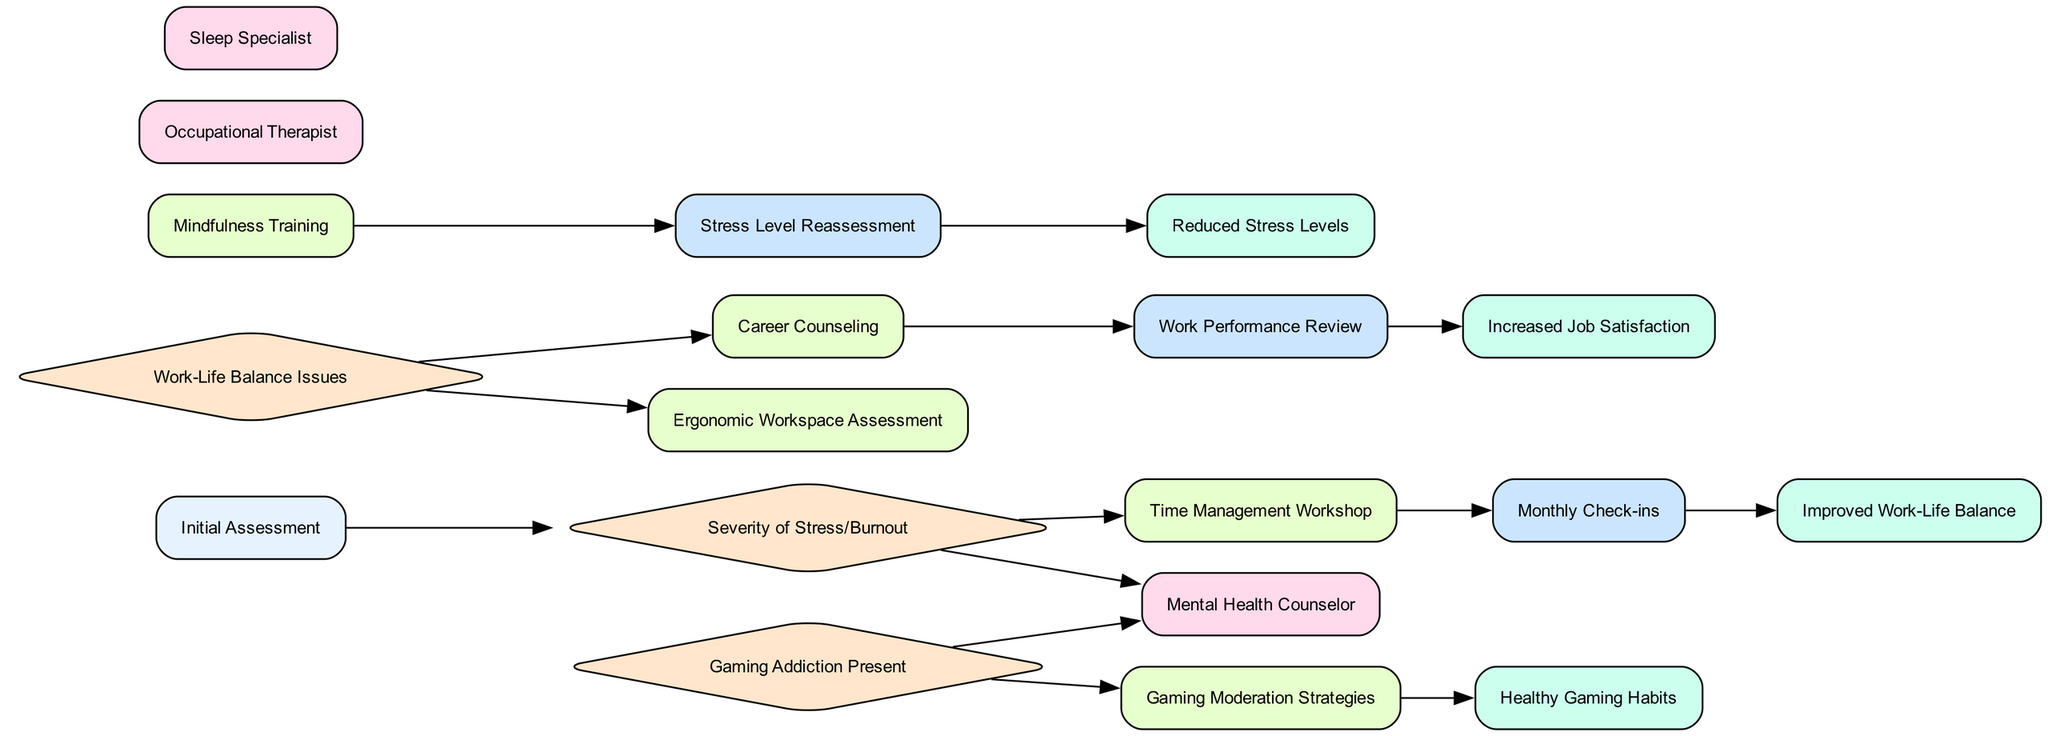What's the start point of the clinical pathway? The start point in the diagram is labeled as "Initial Assessment," which indicates the beginning of the clinical pathway and the first action taken.
Answer: Initial Assessment How many decision points are there in the diagram? By examining the diagram, we can count three clear decision points: "Severity of Stress/Burnout," "Work-Life Balance Issues," and "Gaming Addiction Present." Therefore, the total is three.
Answer: 3 What intervention is connected to 'Severity of Stress/Burnout'? The intervention directly connected to 'Severity of Stress/Burnout' is "Time Management Workshop," indicating a response based on the assessment of stress levels.
Answer: Time Management Workshop Which outcome results from 'Monthly Check-ins'? The outcome resulting from 'Monthly Check-ins' is "Improved Work-Life Balance," showing the positive effect of consistent monitoring on professionals' balance between work and personal life.
Answer: Improved Work-Life Balance What are the referrals related to the 'Gaming Addiction Present' decision point? The referrals linked to 'Gaming Addiction Present' are "Gaming Moderation Strategies" and "Mental Health Counselor." This shows the pathways that emerge when gaming addiction is identified as an issue.
Answer: Gaming Moderation Strategies, Mental Health Counselor Which intervention leads to the 'Work Performance Review'? The intervention that leads to 'Work Performance Review' is "Career Counseling," showing that after counseling, there is an evaluation of work performance based on the guidance received.
Answer: Career Counseling What is the final outcome in this clinical pathway? The final outcome in the diagram is "Healthy Gaming Habits," which suggests that the pathway concludes with improved behaviors related to gaming if previously identified as a concern.
Answer: Healthy Gaming Habits Which two interventions follow 'Stress Level Reassessment'? The two interventions following 'Stress Level Reassessment' are "Stress Level Reassessment" and "Increased Job Satisfaction." This means that following the reassessment, there's a measure of how job satisfaction has changed as a result of prior interventions.
Answer: Increased Job Satisfaction Is there a connection between 'Mindfulness Training' and an outcome? Yes, 'Mindfulness Training' connects directly to 'Stress Level Reassessment,' indicating that the training leads to a reevaluation of stress levels, which is an important step in measuring effectiveness.
Answer: Stress Level Reassessment 